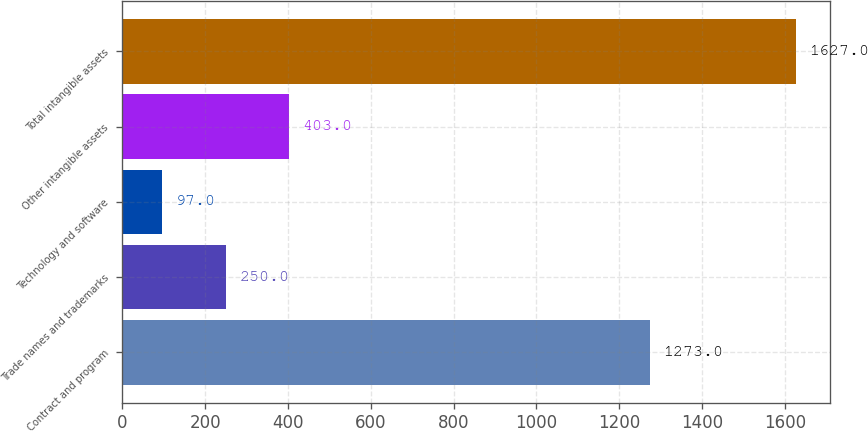Convert chart. <chart><loc_0><loc_0><loc_500><loc_500><bar_chart><fcel>Contract and program<fcel>Trade names and trademarks<fcel>Technology and software<fcel>Other intangible assets<fcel>Total intangible assets<nl><fcel>1273<fcel>250<fcel>97<fcel>403<fcel>1627<nl></chart> 